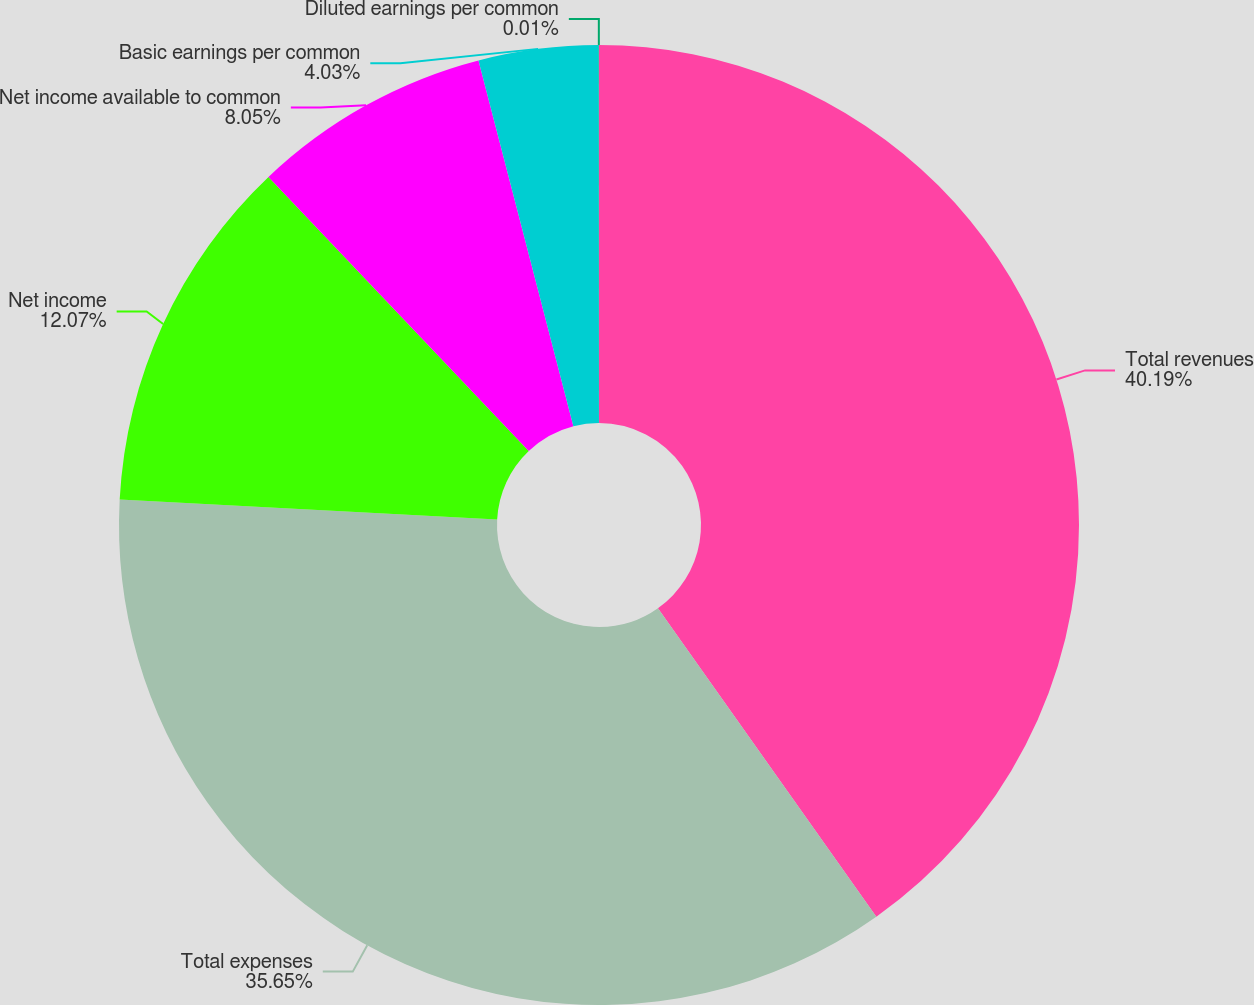Convert chart. <chart><loc_0><loc_0><loc_500><loc_500><pie_chart><fcel>Total revenues<fcel>Total expenses<fcel>Net income<fcel>Net income available to common<fcel>Basic earnings per common<fcel>Diluted earnings per common<nl><fcel>40.2%<fcel>35.65%<fcel>12.07%<fcel>8.05%<fcel>4.03%<fcel>0.01%<nl></chart> 